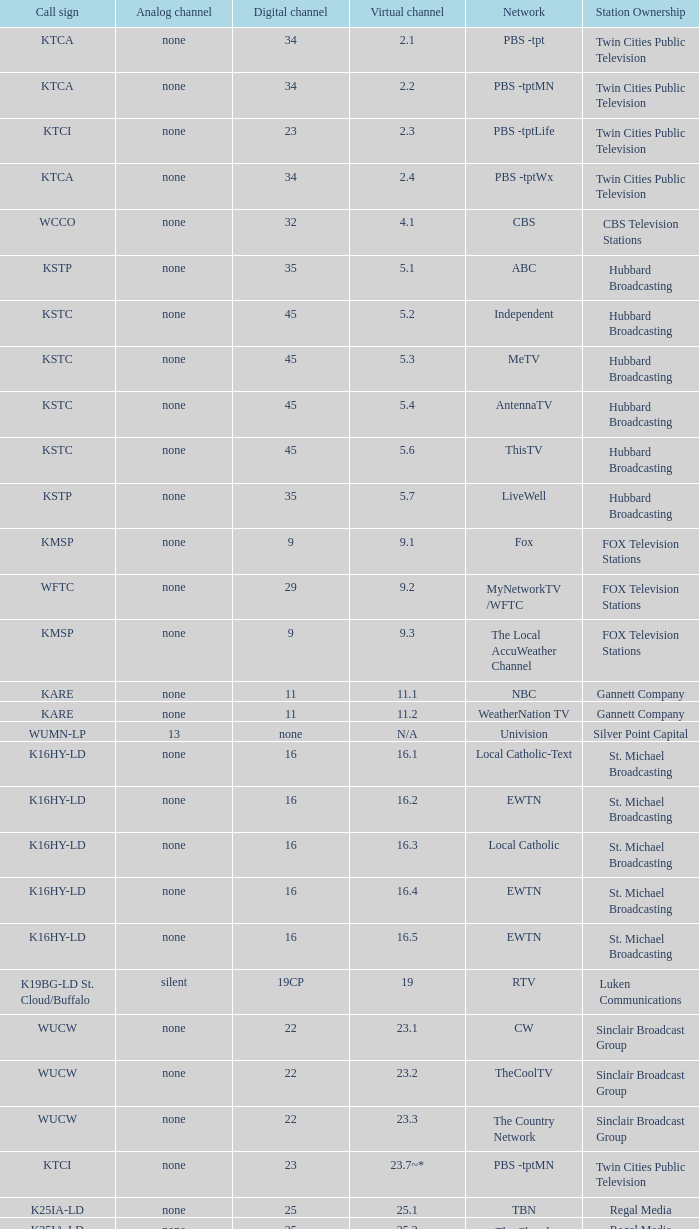For the call sign k43hb-ld, what is the related virtual channel? 43.1. 